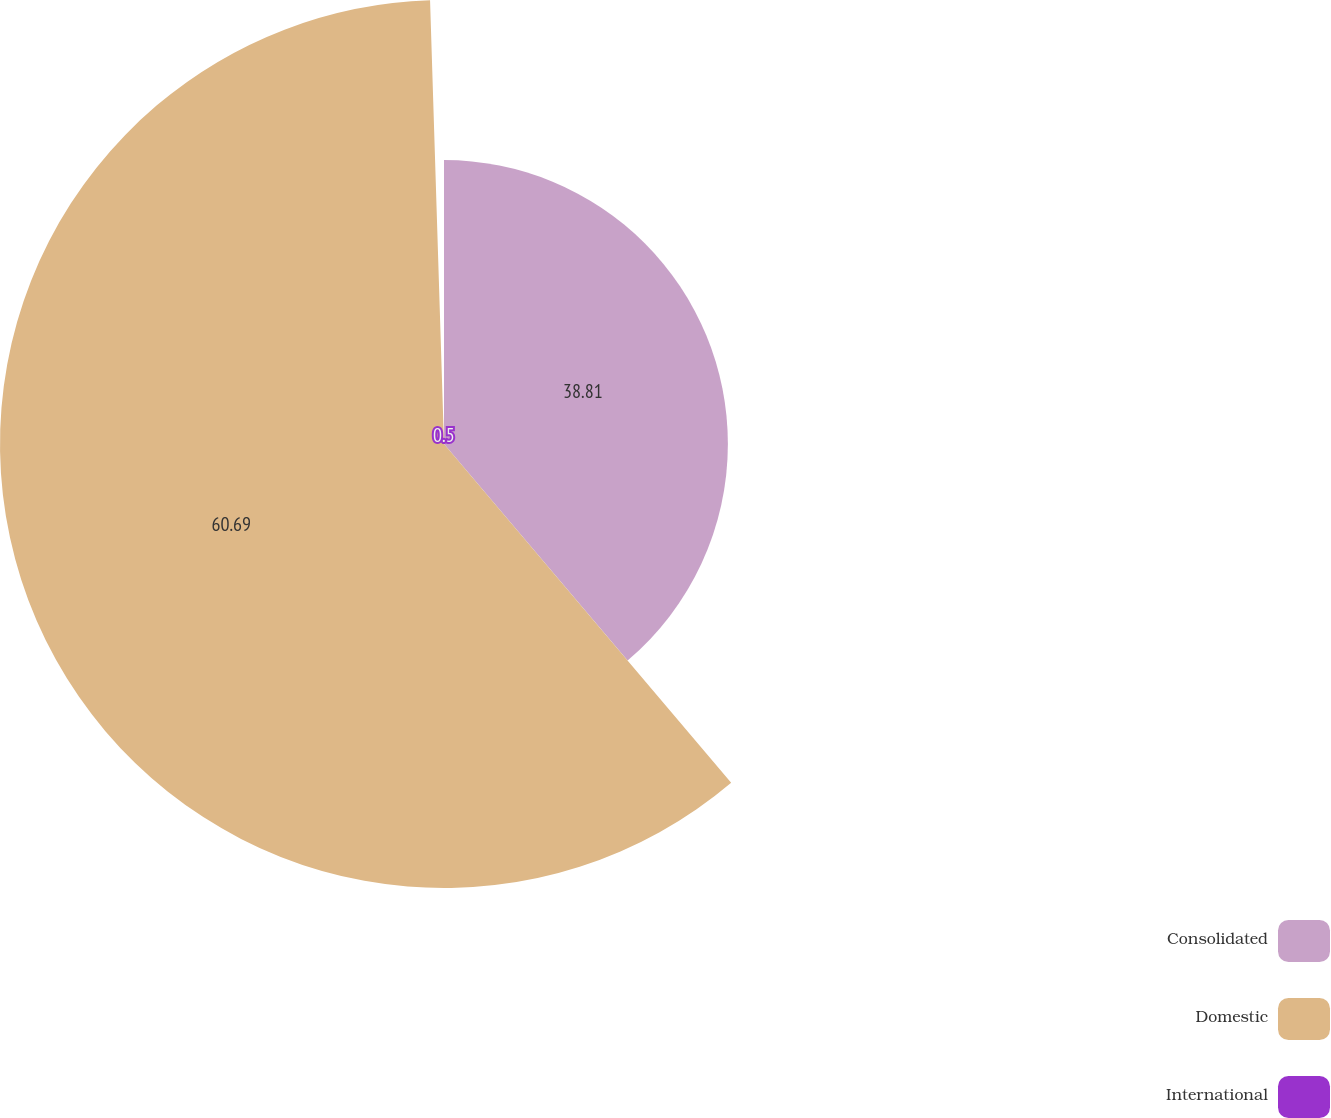Convert chart. <chart><loc_0><loc_0><loc_500><loc_500><pie_chart><fcel>Consolidated<fcel>Domestic<fcel>International<nl><fcel>38.81%<fcel>60.7%<fcel>0.5%<nl></chart> 